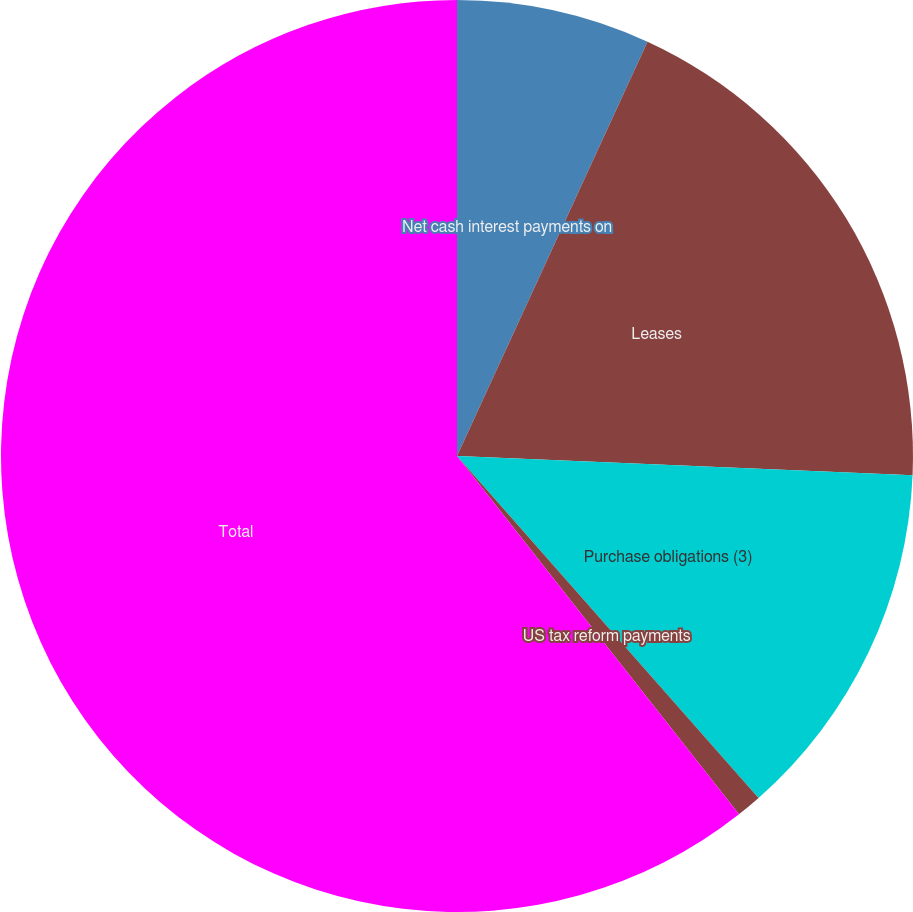Convert chart to OTSL. <chart><loc_0><loc_0><loc_500><loc_500><pie_chart><fcel>Net cash interest payments on<fcel>Leases<fcel>Purchase obligations (3)<fcel>US tax reform payments<fcel>Total<nl><fcel>6.86%<fcel>18.81%<fcel>12.83%<fcel>0.89%<fcel>60.61%<nl></chart> 